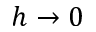Convert formula to latex. <formula><loc_0><loc_0><loc_500><loc_500>h \rightarrow 0</formula> 